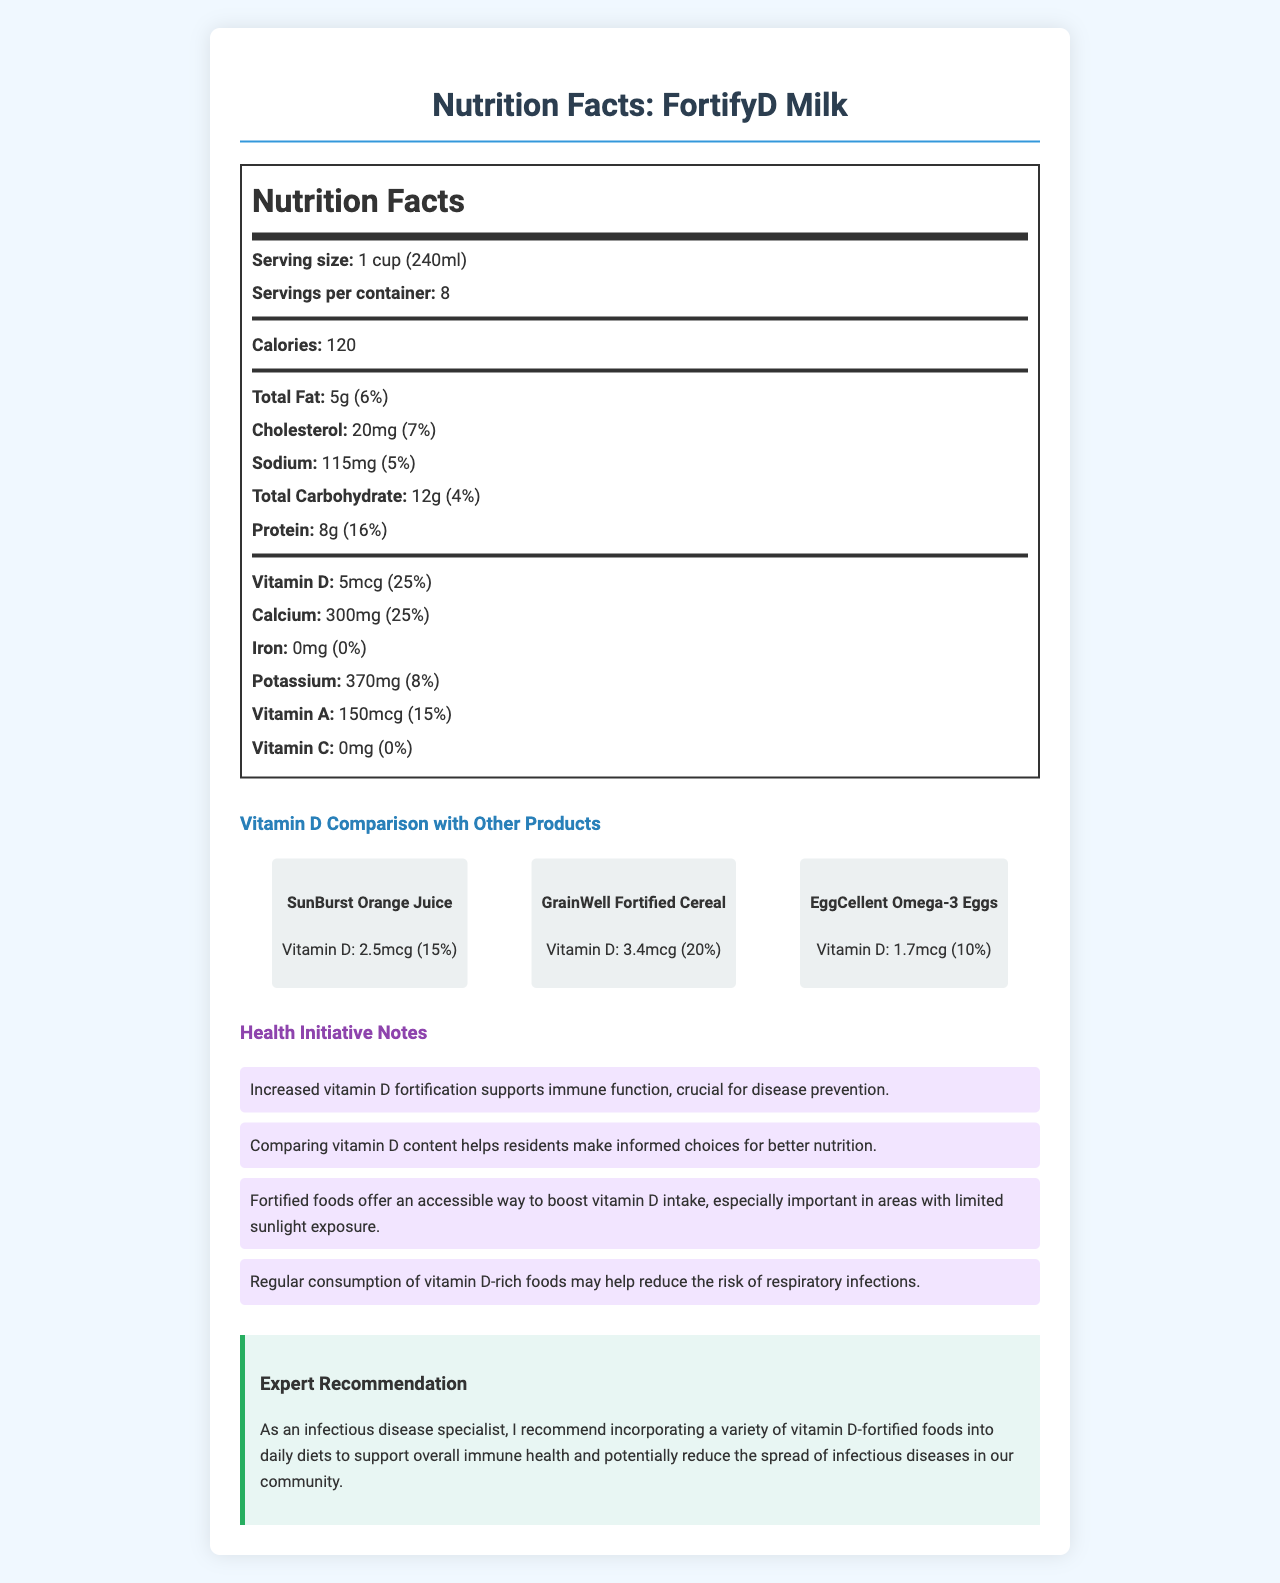what is the serving size of FortifyD Milk? The serving size of FortifyD Milk is mentioned at the beginning of the Nutrition Facts label as "1 cup (240ml)".
Answer: 1 cup (240ml) how many servings are there per container of FortifyD Milk? The document states that there are 8 servings per container of FortifyD Milk.
Answer: 8 what is the vitamin D content in one serving of FortifyD Milk? The Nutrition Facts label for FortifyD Milk mentions that the vitamin D content in one serving is 5mcg.
Answer: 5mcg how much of the daily value of vitamin D does one serving of FortifyD Milk provide? The label shows that one serving of FortifyD Milk provides 25% of the daily value of vitamin D.
Answer: 25% what are three vitamins or minerals that FortifyD Milk provides, other than vitamin D? The Nutrition Facts label lists Calcium, Potassium, and Vitamin A among the vitamins and minerals present besides Vitamin D.
Answer: Calcium, Potassium, Vitamin A which product has the highest vitamin D content? A. FortifyD Milk B. SunBurst Orange Juice C. GrainWell Fortified Cereal D. EggCellent Omega-3 Eggs The comparison chart shows that FortifyD Milk has 5mcg of Vitamin D, which is higher than the Vitamin D content in the other listed products.
Answer: A. FortifyD Milk which of the following products has the lowest vitamin D percentage of daily value? i. FortifyD Milk ii. SunBurst Orange Juice iii. GrainWell Fortified Cereal iv. EggCellent Omega-3 Eggs EggCellent Omega-3 Eggs has the lowest percentage of the daily value of Vitamin D at 10%.
Answer: iv. EggCellent Omega-3 Eggs does FortifyD Milk contain any iron? The Nutrition Facts label for FortifyD Milk states that it contains 0mg of iron.
Answer: No is the vitamin C content in FortifyD Milk significant? The label shows that there is 0mg of Vitamin C in FortifyD Milk, indicating it has no significant vitamin C content.
Answer: No how does the document support boosting vitamin D intake in the community? The health initiative notes and expert recommendation sections discuss the benefits of increased vitamin D intake for immune support and disease prevention, as well as providing a comparative analysis of fortified foods high in vitamin D.
Answer: The document explains that increased vitamin D fortification supports immune function, helps residents make informed nutrition choices, and emphasizes the importance of vitamin D-rich foods in areas with limited sunlight to reduce respiratory infections. how many calories are there in one serving of FortifyD Milk? The Nutrition Facts label states that one serving of FortifyD Milk contains 120 calories.
Answer: 120 what is one health benefit mentioned in relation to vitamin D in the document? One of the health initiative notes mentions that increased vitamin D fortification supports immune function, which is crucial for disease prevention.
Answer: Supports immune function, crucial for disease prevention what is the main idea of the FortifyD Milk Nutrition Facts label document? The certificate includes detailed nutritional information of FortifyD Milk, comparison of its vitamin D content with other products, health initiative notes emphasizing vitamin D benefits, and an expert's recommendation on dietary vitamin D fortification.
Answer: The document provides a detailed nutritional analysis of FortifyD Milk, compares its vitamin D content with other fortified products, highlights the importance of vitamin D fortification for community health, and includes an expert recommendation to incorporate a variety of vitamin D-fortified foods into daily diets to support immune health and potentially reduce the spread of infectious diseases. what year were these nutrition facts determined? The document does not provide any information regarding the year these nutrition facts were determined.
Answer: Not enough information 